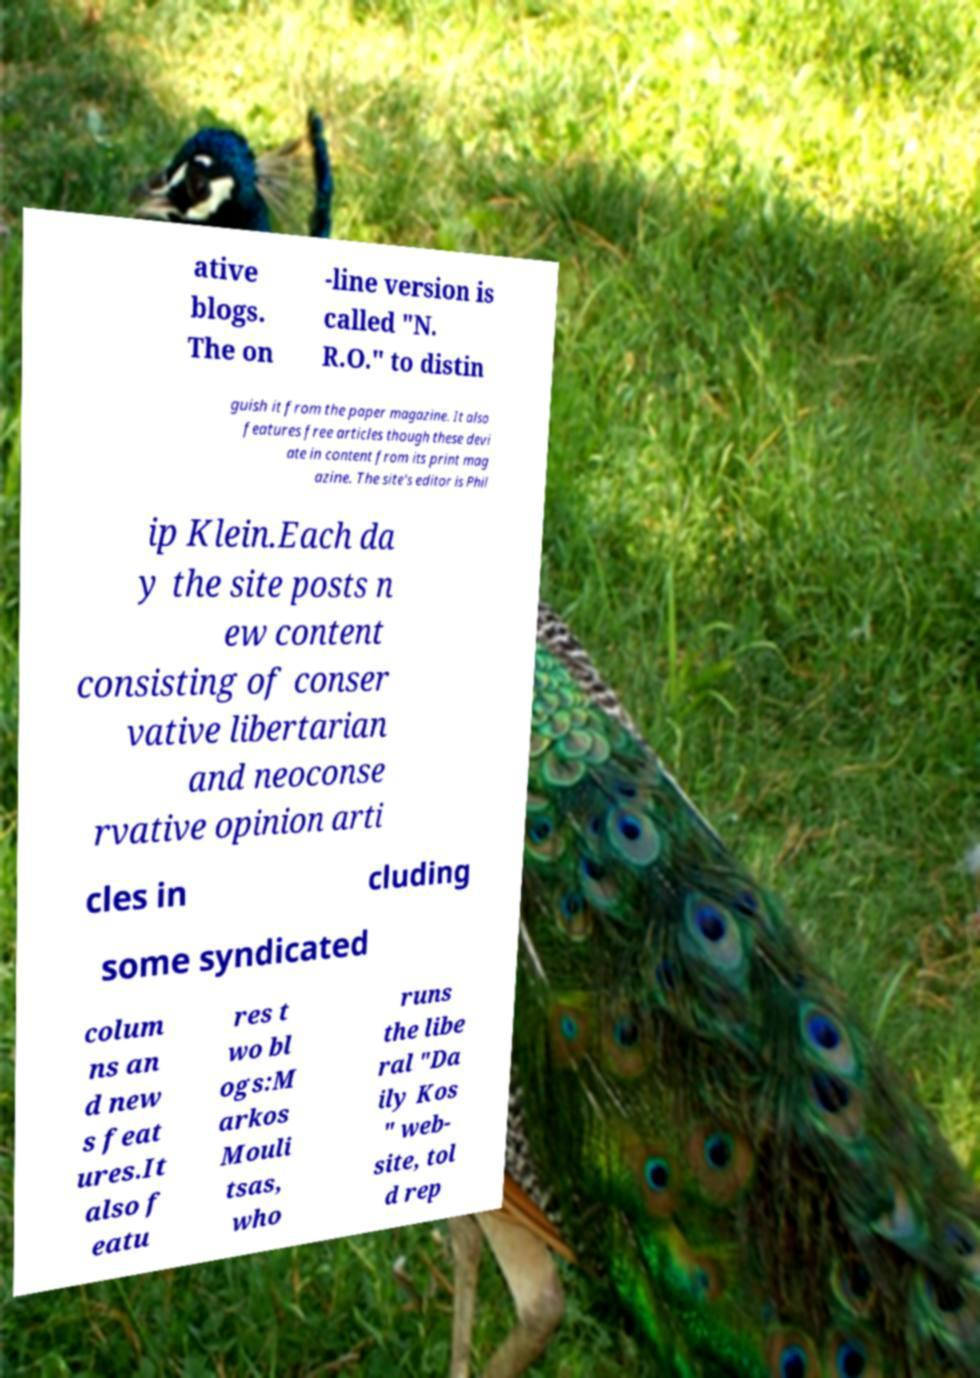For documentation purposes, I need the text within this image transcribed. Could you provide that? ative blogs. The on -line version is called "N. R.O." to distin guish it from the paper magazine. It also features free articles though these devi ate in content from its print mag azine. The site's editor is Phil ip Klein.Each da y the site posts n ew content consisting of conser vative libertarian and neoconse rvative opinion arti cles in cluding some syndicated colum ns an d new s feat ures.It also f eatu res t wo bl ogs:M arkos Mouli tsas, who runs the libe ral "Da ily Kos " web- site, tol d rep 